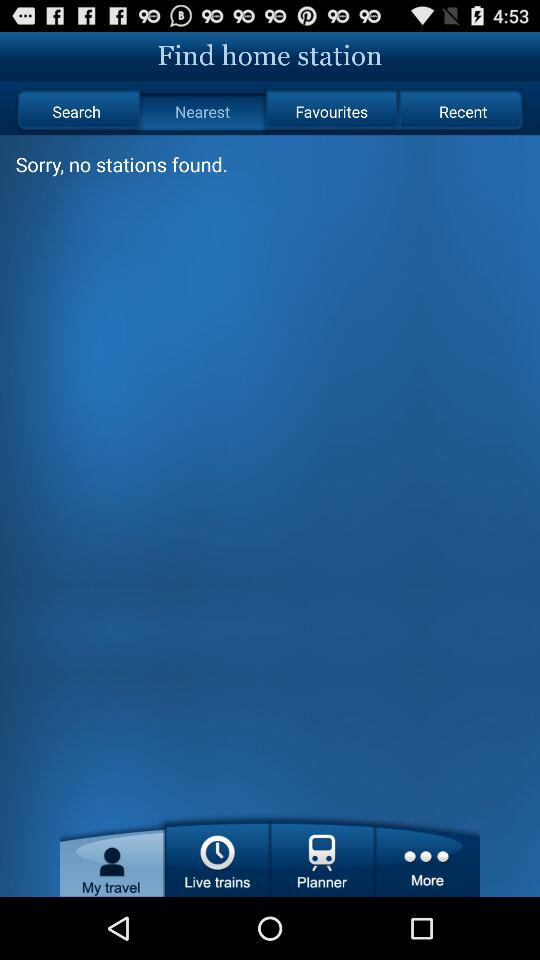Which tab am I on? You are on "Nearest" and "My travel" tabs. 